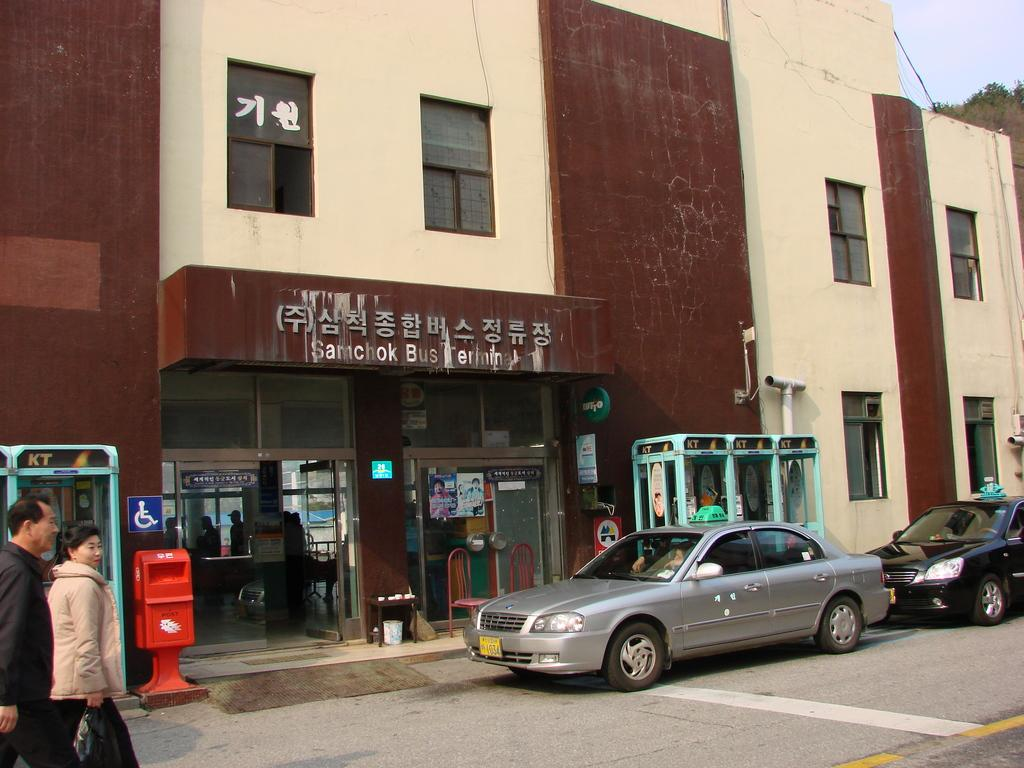What type of structure is present in the image? There is a building in the image. What mode of transportation can be seen in the image? There is a car in the image. Are there any people visible in the image? Yes, there is a person in the image. What type of furniture is present in the image? There is a chair in the image. What can be seen in the background of the image? The sky is visible in the image. What direction is the boat heading in the image? There is no boat present in the image. What color is the person's tongue in the image? There is no mention of a tongue in the image, so it cannot be determined. 